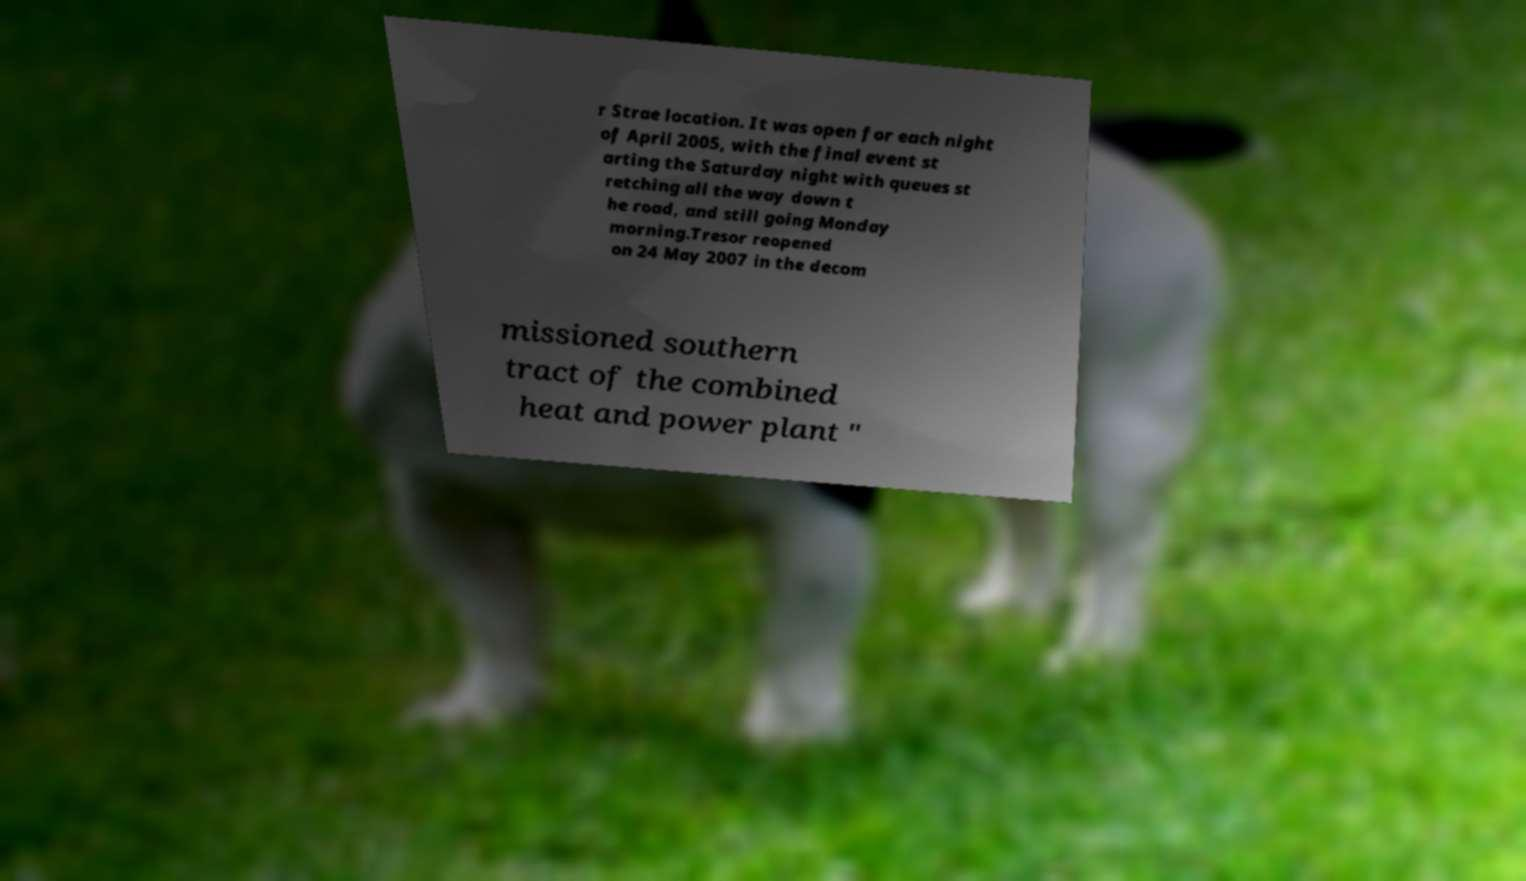Could you extract and type out the text from this image? r Strae location. It was open for each night of April 2005, with the final event st arting the Saturday night with queues st retching all the way down t he road, and still going Monday morning.Tresor reopened on 24 May 2007 in the decom missioned southern tract of the combined heat and power plant " 